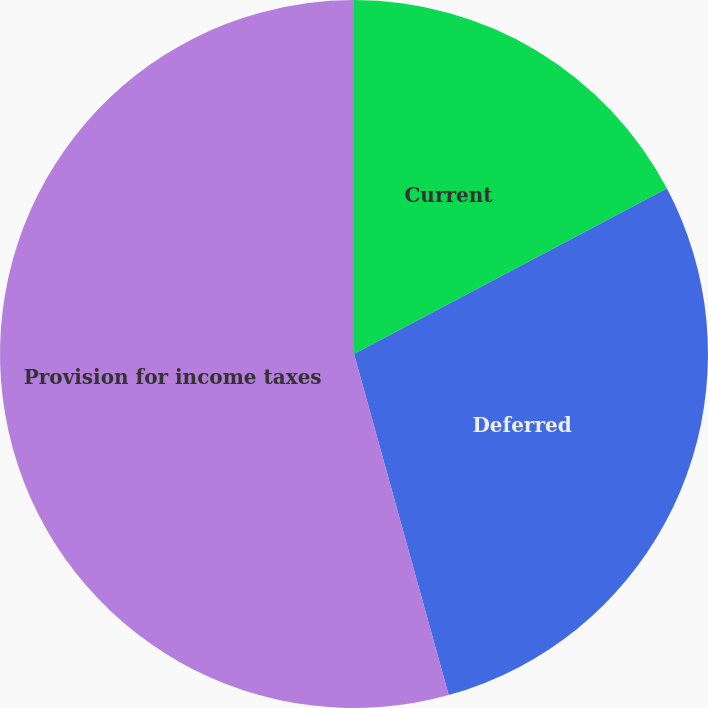<chart> <loc_0><loc_0><loc_500><loc_500><pie_chart><fcel>Current<fcel>Deferred<fcel>Provision for income taxes<nl><fcel>17.26%<fcel>28.43%<fcel>54.31%<nl></chart> 